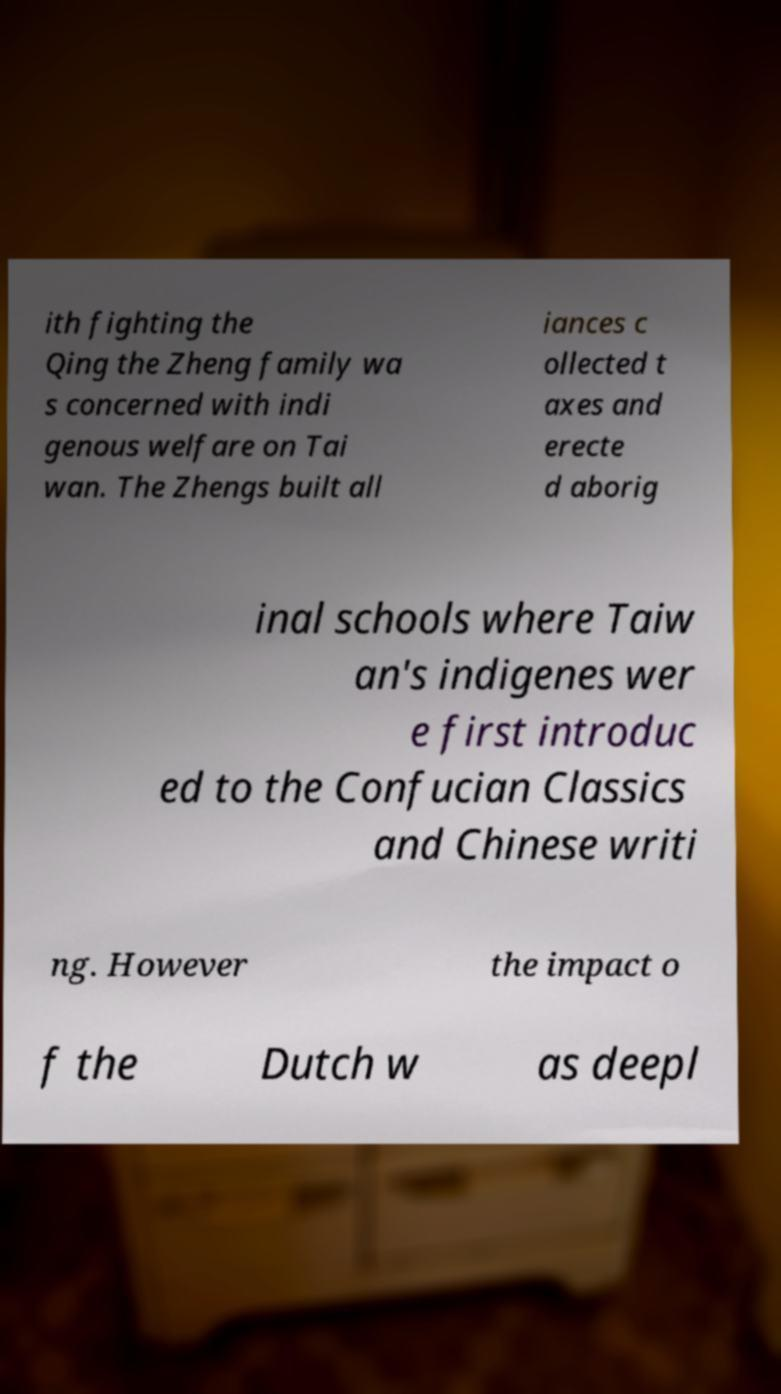Can you read and provide the text displayed in the image?This photo seems to have some interesting text. Can you extract and type it out for me? ith fighting the Qing the Zheng family wa s concerned with indi genous welfare on Tai wan. The Zhengs built all iances c ollected t axes and erecte d aborig inal schools where Taiw an's indigenes wer e first introduc ed to the Confucian Classics and Chinese writi ng. However the impact o f the Dutch w as deepl 